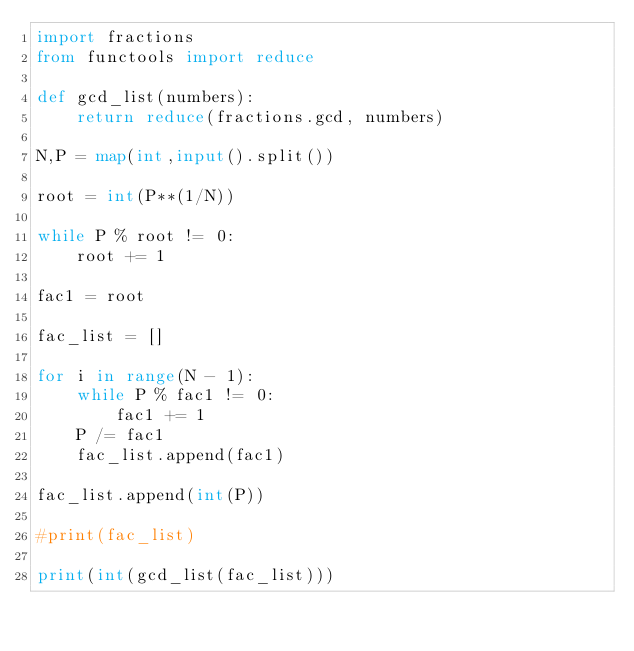<code> <loc_0><loc_0><loc_500><loc_500><_Python_>import fractions
from functools import reduce

def gcd_list(numbers):
    return reduce(fractions.gcd, numbers)

N,P = map(int,input().split())

root = int(P**(1/N))

while P % root != 0:
    root += 1

fac1 = root

fac_list = []

for i in range(N - 1):
    while P % fac1 != 0:
        fac1 += 1
    P /= fac1
    fac_list.append(fac1)

fac_list.append(int(P))

#print(fac_list)

print(int(gcd_list(fac_list)))
</code> 